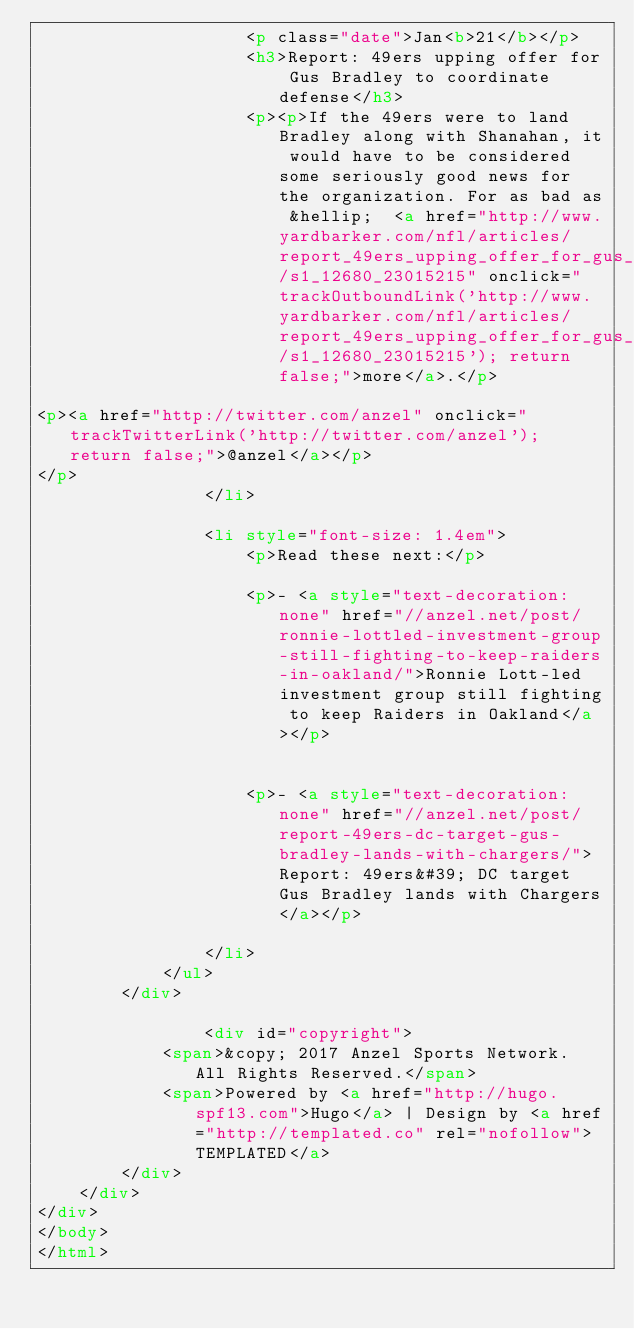Convert code to text. <code><loc_0><loc_0><loc_500><loc_500><_HTML_>					<p class="date">Jan<b>21</b></p>
					<h3>Report: 49ers upping offer for Gus Bradley to coordinate defense</h3>
					<p><p>If the 49ers were to land Bradley along with Shanahan, it would have to be considered some seriously good news for the organization. For as bad as &hellip;  <a href="http://www.yardbarker.com/nfl/articles/report_49ers_upping_offer_for_gus_bradley_to_coordinate_defense/s1_12680_23015215" onclick="trackOutboundLink('http://www.yardbarker.com/nfl/articles/report_49ers_upping_offer_for_gus_bradley_to_coordinate_defense/s1_12680_23015215'); return false;">more</a>.</p>

<p><a href="http://twitter.com/anzel" onclick="trackTwitterLink('http://twitter.com/anzel'); return false;">@anzel</a></p>
</p>
				</li>

				<li style="font-size: 1.4em">
					<p>Read these next:</p>
					
					<p>- <a style="text-decoration: none" href="//anzel.net/post/ronnie-lottled-investment-group-still-fighting-to-keep-raiders-in-oakland/">Ronnie Lott-led investment group still fighting to keep Raiders in Oakland</a></p>
					
					
					<p>- <a style="text-decoration: none" href="//anzel.net/post/report-49ers-dc-target-gus-bradley-lands-with-chargers/">Report: 49ers&#39; DC target Gus Bradley lands with Chargers</a></p>
					
				</li>
			</ul>
		</div>

				<div id="copyright">
			<span>&copy; 2017 Anzel Sports Network. All Rights Reserved.</span>
			<span>Powered by <a href="http://hugo.spf13.com">Hugo</a> | Design by <a href="http://templated.co" rel="nofollow">TEMPLATED</a>
		</div>
	</div>
</div>
</body>
</html>

</code> 